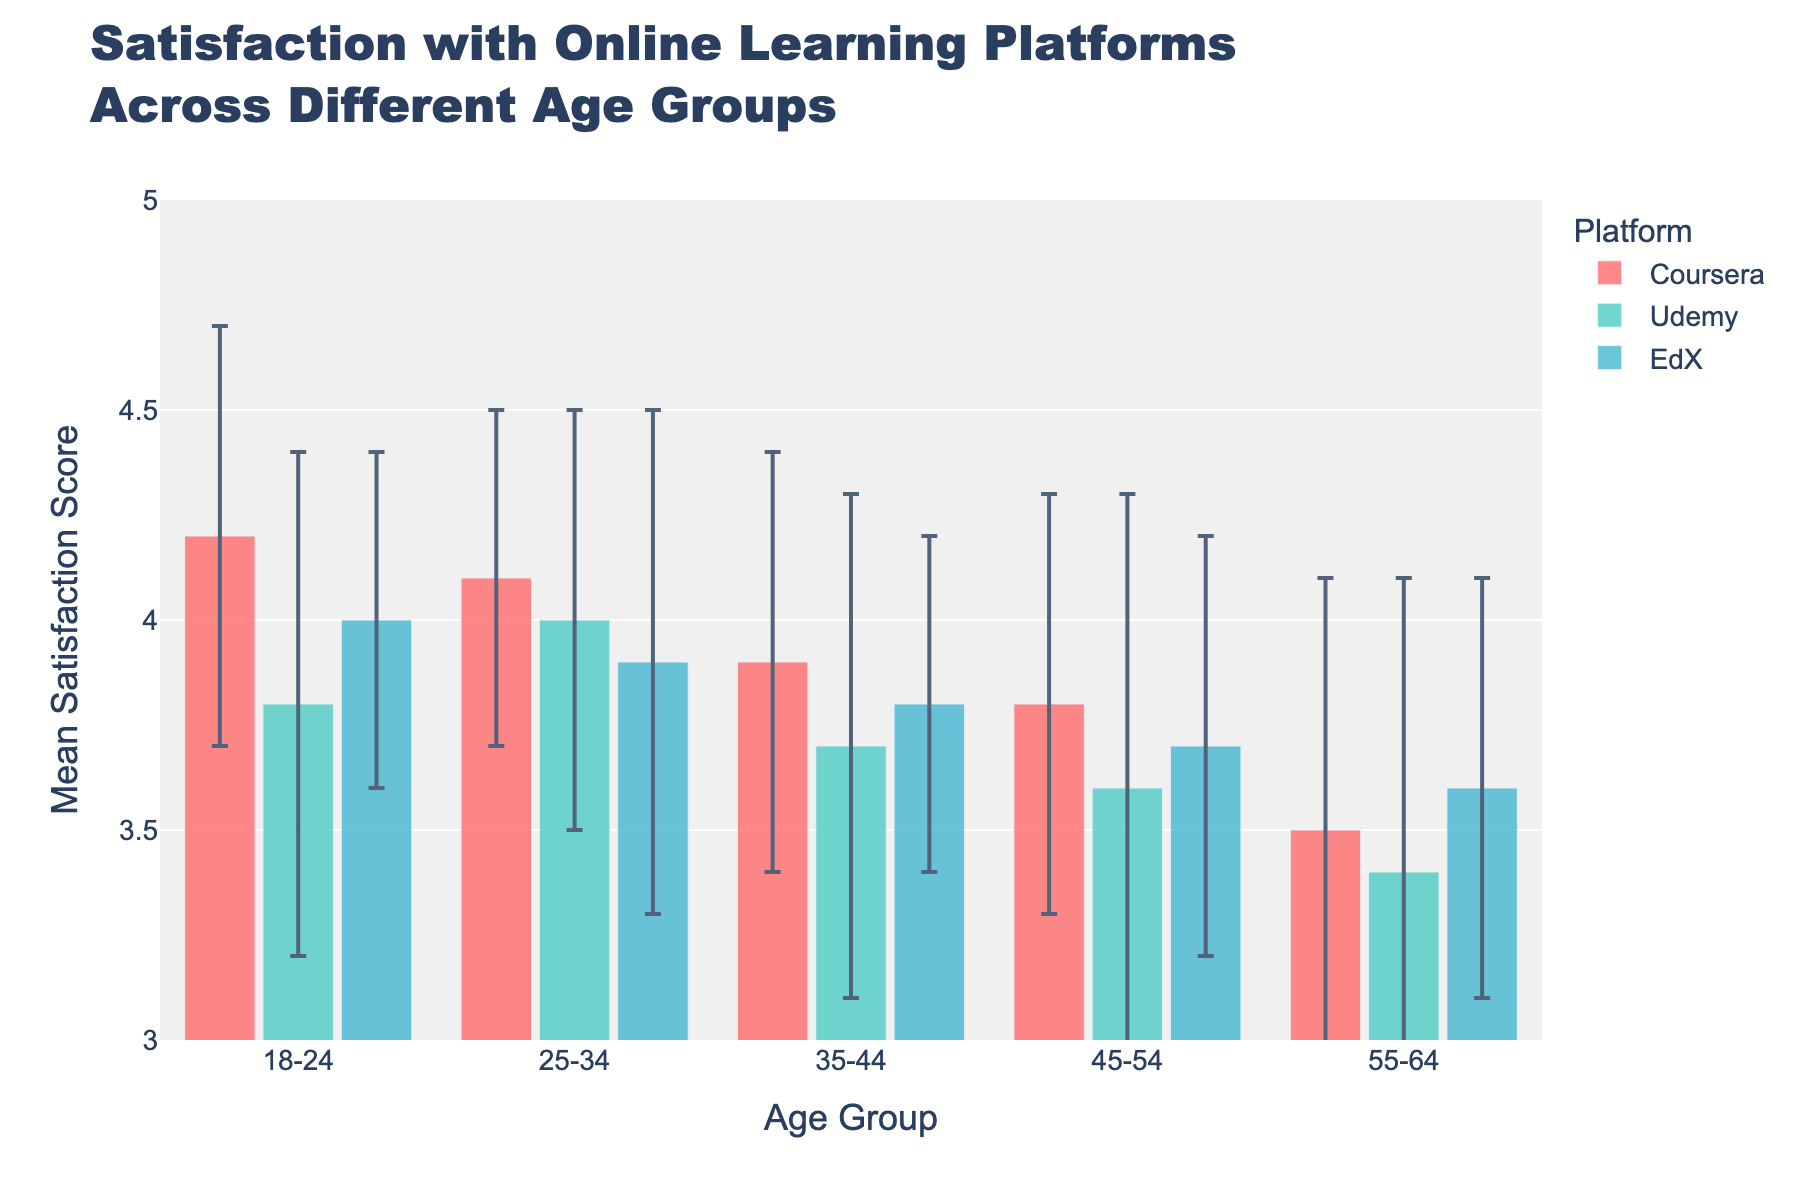What is the title of the figure? The title of the figure is displayed at the top of the plot. It reads "Satisfaction with Online Learning Platforms Across Different Age Groups".
Answer: Satisfaction with Online Learning Platforms Across Different Age Groups Which age group has the highest mean satisfaction for Coursera? By comparing all the bars representing Coursera across different age groups, the highest mean satisfaction is found in the 18-24 age group with a mean score of 4.2.
Answer: 18-24 What is the mean satisfaction score of Udemy for the 45-54 age group? Look at the bar corresponding to Udemy for the 45-54 age group. The mean satisfaction score for Udemy in this age group is 3.6.
Answer: 3.6 Which platform shows the highest variability in satisfaction scores across all age groups? The platform with the highest variability can be identified by comparing the error bars across all platforms and age groups. Udemy tends to have the largest error bars, indicating higher variability.
Answer: Udemy What is the mean satisfaction score for EdX in the 25-34 age group minus the mean satisfaction score for Udemy in the same age group? The mean satisfaction score for EdX in the 25-34 age group is 3.9, and for Udemy, it's 4.0. Subtracting these values gives 3.9 - 4.0.
Answer: -0.1 Which age group has the lowest mean satisfaction score for any of the platforms, and what is that score? Compare the mean satisfaction scores across all platforms and age groups. The lowest score is found for Udemy in the 55-64 age group with a mean score of 3.4.
Answer: 55-64, 3.4 How does the satisfaction with Coursera for the 35-44 age group compare to the satisfaction with EdX for the same age group? For the 35-44 age group, the mean satisfaction score for Coursera is 3.9 and for EdX is 3.8. Therefore, Coursera has a slightly higher satisfaction than EdX in this age group.
Answer: Coursera is higher by 0.1 What is the average mean satisfaction score for Coursera across all age groups? To find this, sum all the mean satisfaction scores for Coursera (4.2, 4.1, 3.9, 3.8, 3.5) and divide by the number of age groups (5). The average is (4.2 + 4.1 + 3.9 + 3.8 + 3.5) / 5.
Answer: 3.9 Which platform has the highest consistency in satisfaction scores across all age groups, and why? Consistency can be determined by examining which platform has the smallest error bars across age groups. EdX typically has the smallest error bars, indicating the highest consistency in satisfaction scores.
Answer: EdX What is the range of mean satisfaction scores for the age group 18-24 across all platforms? The range is found by subtracting the lowest mean satisfaction score from the highest in the 18-24 age group. The highest mean score is for Coursera (4.2) and the lowest is for Udemy (3.8). The range is 4.2 - 3.8.
Answer: 0.4 